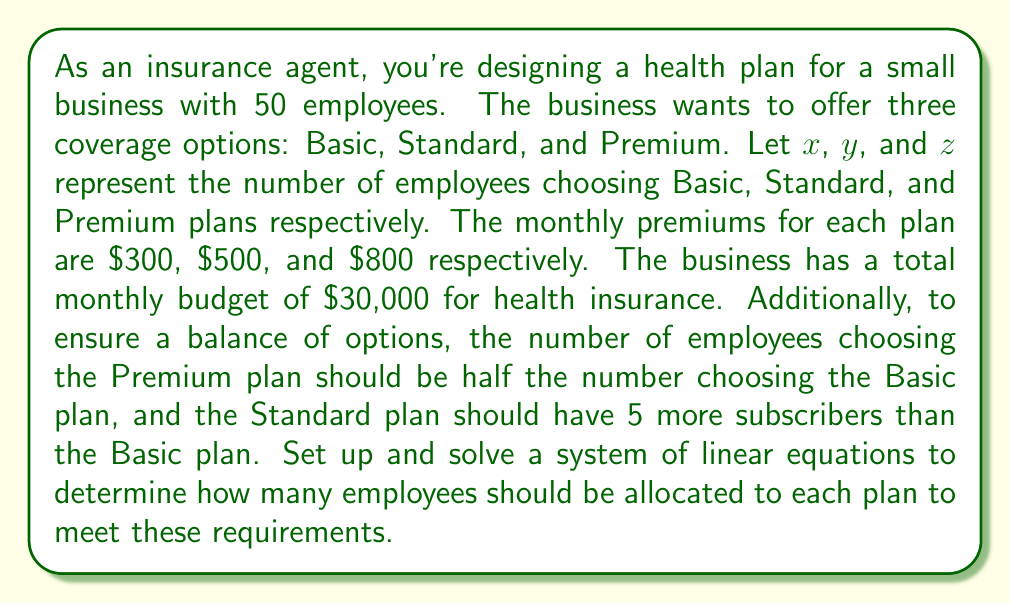What is the answer to this math problem? Let's set up our system of linear equations based on the given information:

1. Total number of employees:
   $x + y + z = 50$

2. Budget constraint:
   $300x + 500y + 800z = 30000$

3. Relationship between Basic and Premium plans:
   $z = \frac{1}{2}x$

4. Relationship between Basic and Standard plans:
   $y = x + 5$

Now, let's solve this system:

Step 1: Substitute the expressions for $y$ and $z$ into the first equation:
$x + (x + 5) + \frac{1}{2}x = 50$
$x + x + 5 + \frac{1}{2}x = 50$
$\frac{5}{2}x + 5 = 50$
$\frac{5}{2}x = 45$
$x = 18$

Step 2: Calculate $y$ and $z$:
$y = x + 5 = 18 + 5 = 23$
$z = \frac{1}{2}x = \frac{1}{2}(18) = 9$

Step 3: Verify the budget constraint:
$300(18) + 500(23) + 800(9) = 5400 + 11500 + 7200 = 24100$

The total cost is $24,100, which is within the $30,000 budget.
Answer: Basic plan (x): 18 employees
Standard plan (y): 23 employees
Premium plan (z): 9 employees 